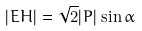<formula> <loc_0><loc_0><loc_500><loc_500>| E H | = { \sqrt { 2 } } | P | \sin \alpha</formula> 